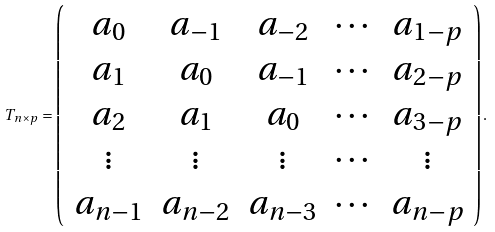Convert formula to latex. <formula><loc_0><loc_0><loc_500><loc_500>T _ { n \times p } = \left ( \begin{array} { c c c c c } a _ { 0 } & a _ { - 1 } & a _ { - 2 } & \cdots & a _ { 1 - p } \\ a _ { 1 } & a _ { 0 } & a _ { - 1 } & \cdots & a _ { 2 - p } \\ a _ { 2 } & a _ { 1 } & a _ { 0 } & \cdots & a _ { 3 - p } \\ \vdots & \vdots & \vdots & \cdots & \vdots \\ a _ { n - 1 } & a _ { n - 2 } & a _ { n - 3 } & \cdots & a _ { n - p } \end{array} \right ) .</formula> 